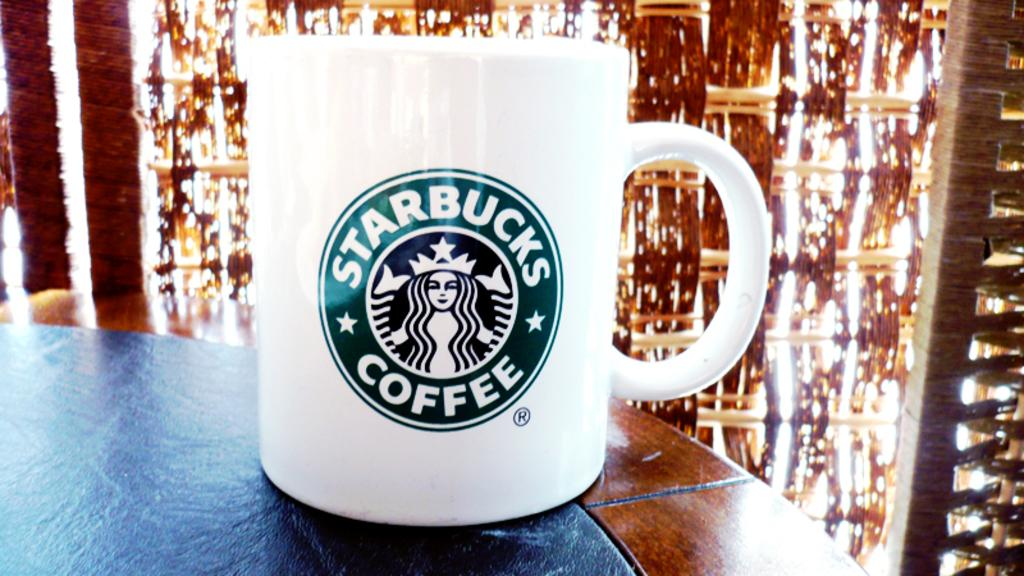<image>
Create a compact narrative representing the image presented. A starbucks coffee mug sitting on a dark table. 